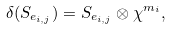Convert formula to latex. <formula><loc_0><loc_0><loc_500><loc_500>\delta ( S _ { e _ { i , j } } ) = S _ { e _ { i , j } } \otimes \chi ^ { m _ { i } } ,</formula> 